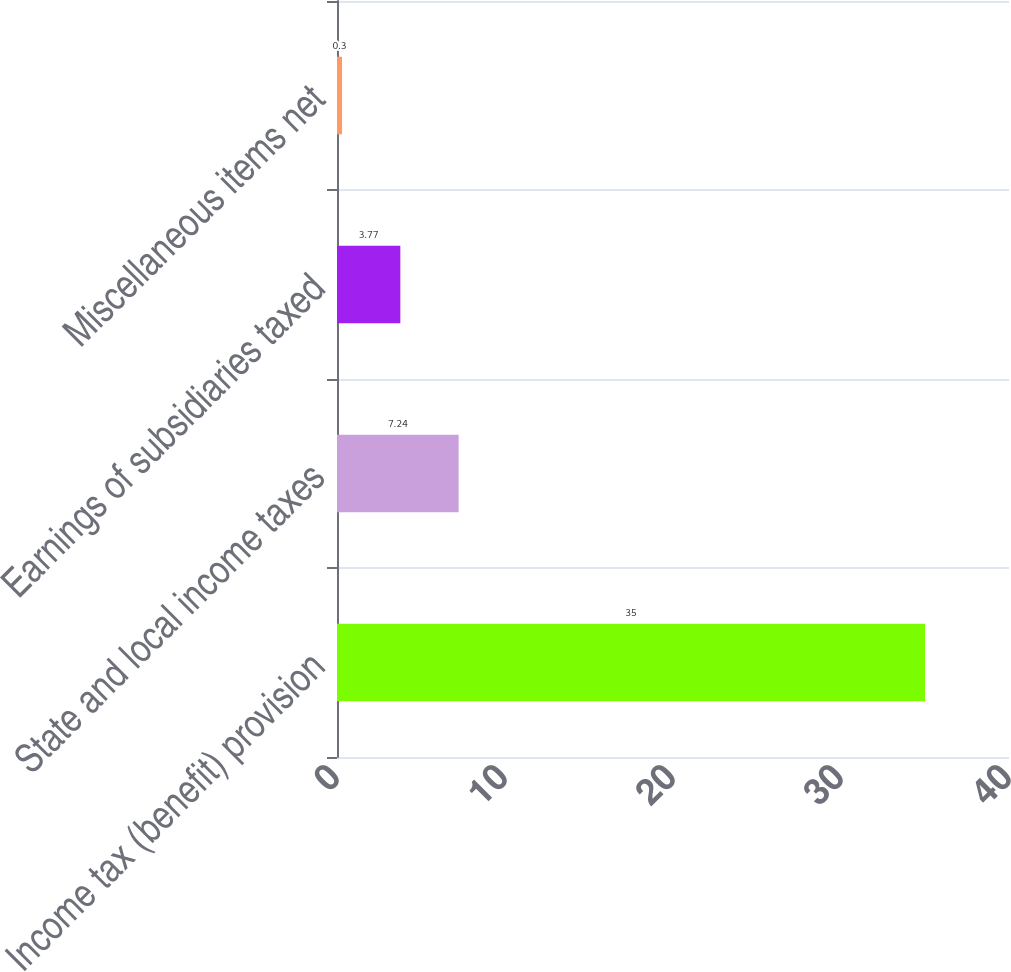Convert chart. <chart><loc_0><loc_0><loc_500><loc_500><bar_chart><fcel>Income tax (benefit) provision<fcel>State and local income taxes<fcel>Earnings of subsidiaries taxed<fcel>Miscellaneous items net<nl><fcel>35<fcel>7.24<fcel>3.77<fcel>0.3<nl></chart> 